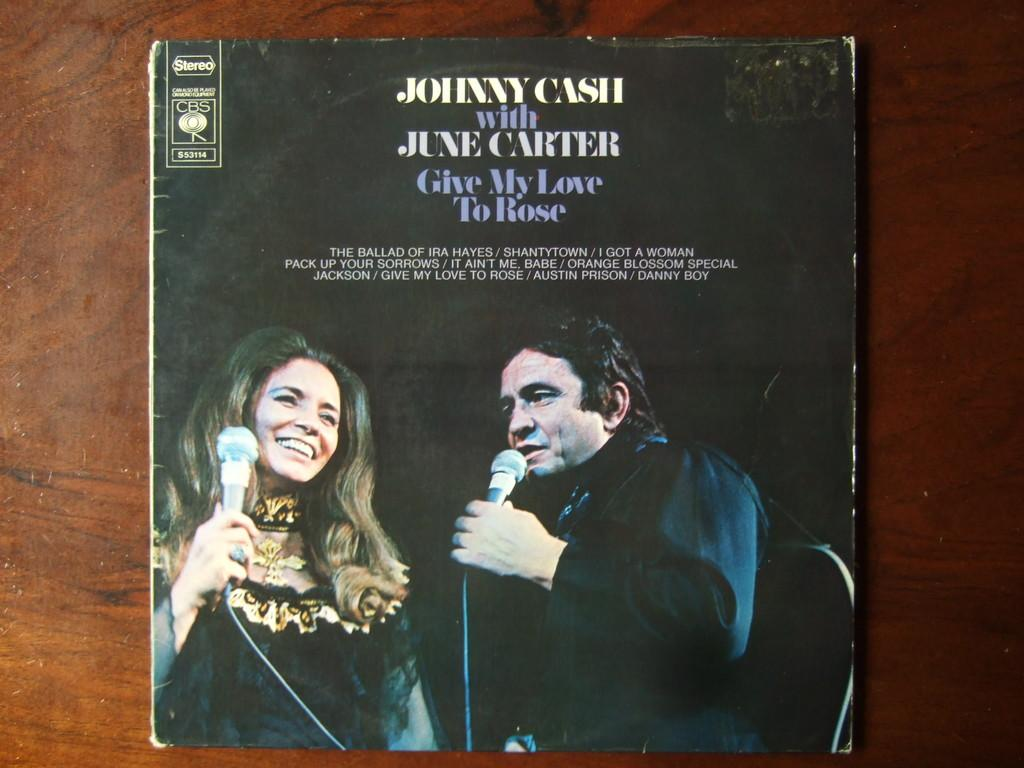<image>
Provide a brief description of the given image. A record case for the album Give My Love To Rose featuring Johnny Cash and June Carter. 